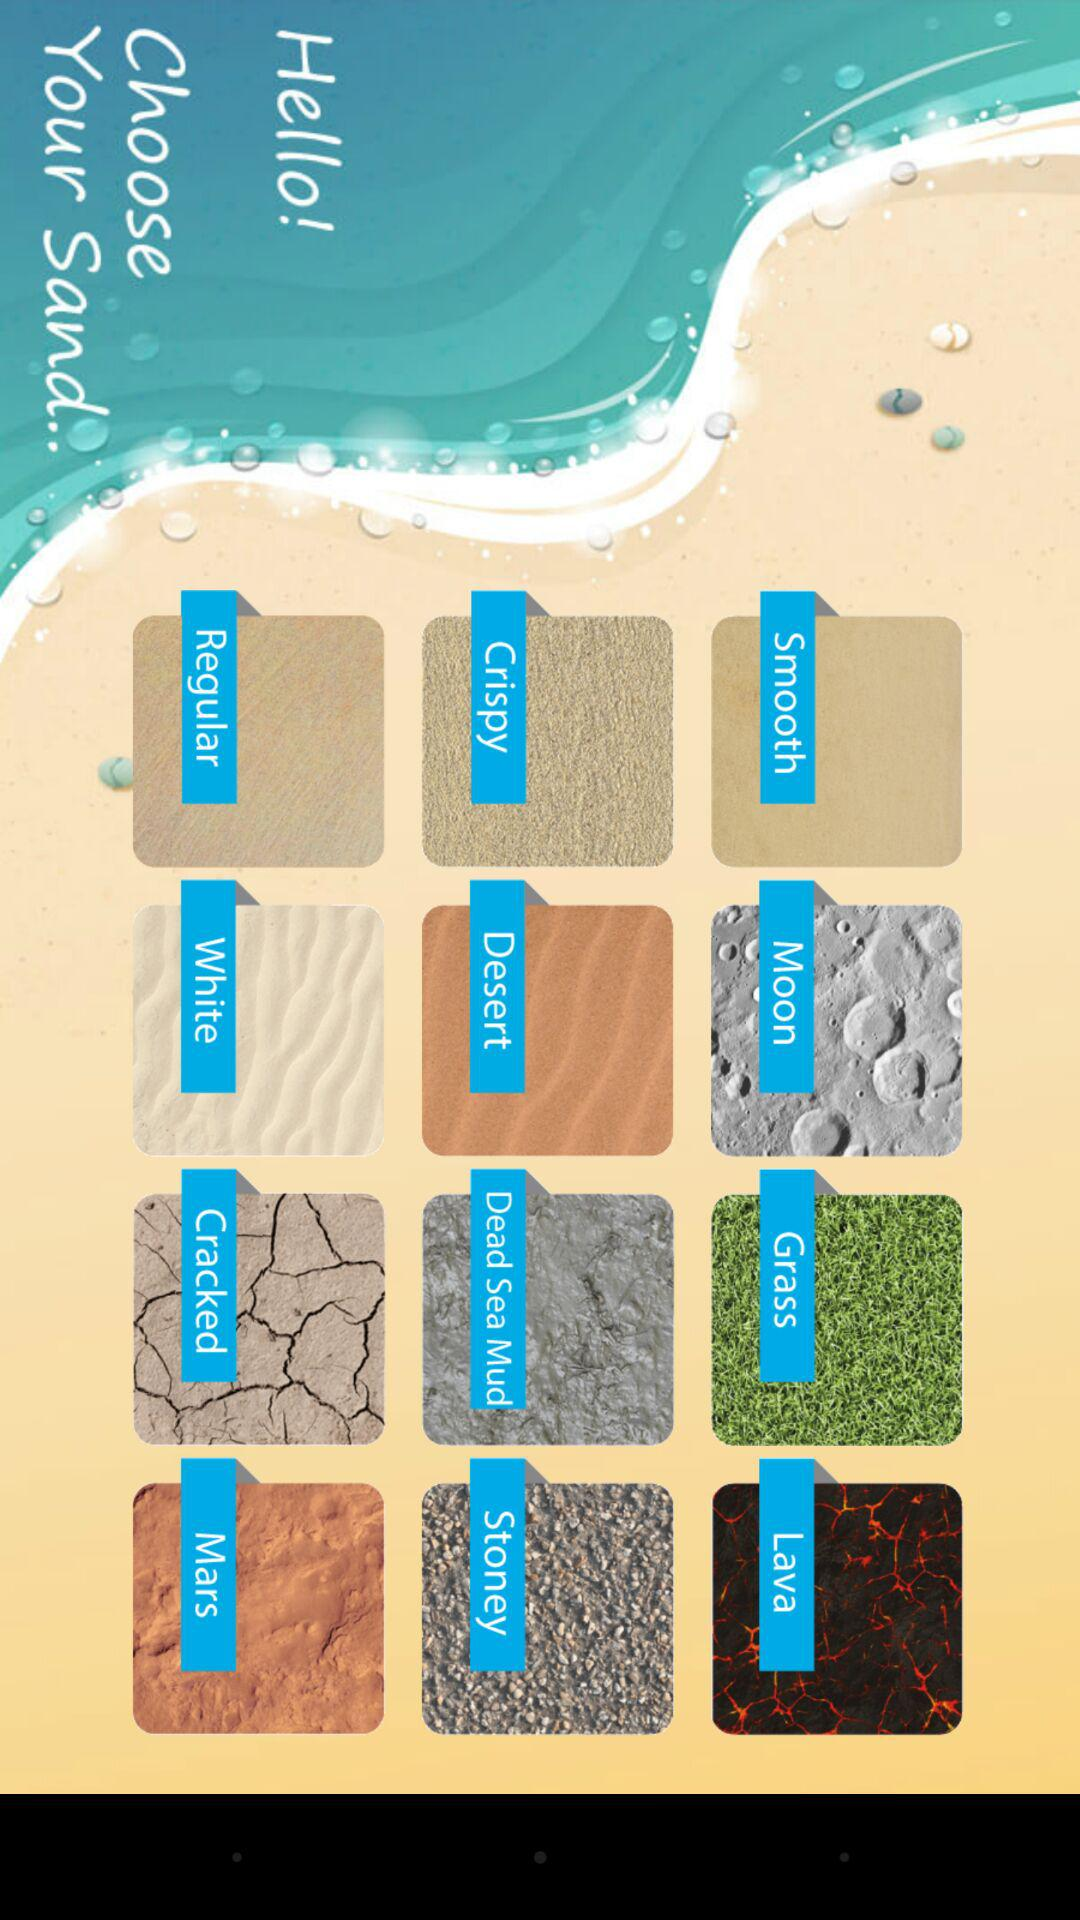How many sand types are there?
Answer the question using a single word or phrase. 12 